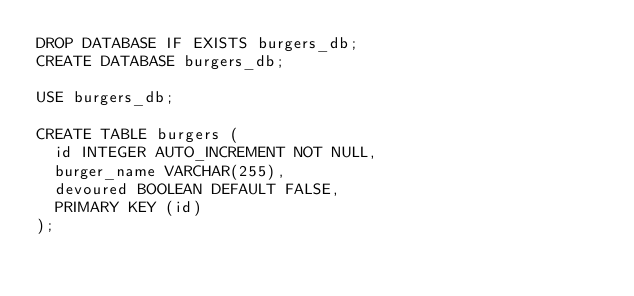Convert code to text. <code><loc_0><loc_0><loc_500><loc_500><_SQL_>DROP DATABASE IF EXISTS burgers_db;
CREATE DATABASE burgers_db;

USE burgers_db;

CREATE TABLE burgers (
  id INTEGER AUTO_INCREMENT NOT NULL,
  burger_name VARCHAR(255),
  devoured BOOLEAN DEFAULT FALSE,
  PRIMARY KEY (id)
);</code> 